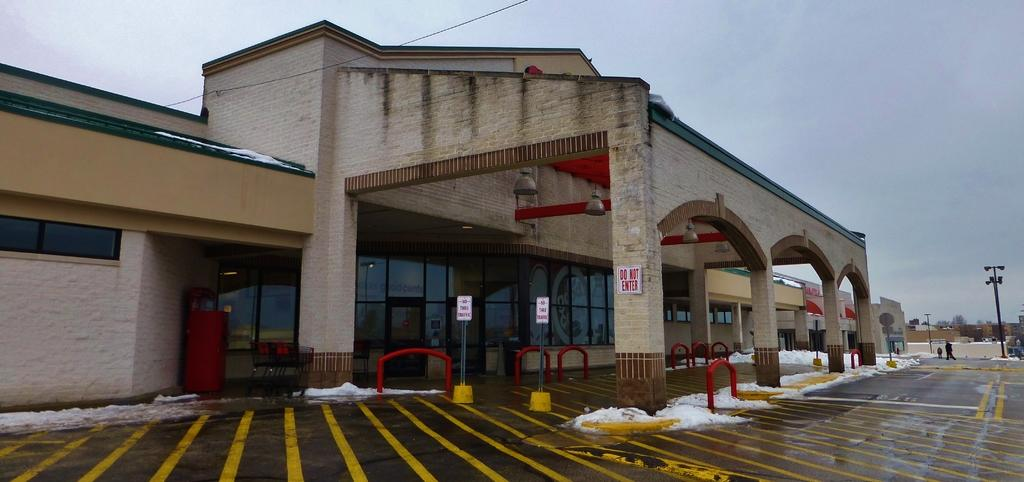<image>
Present a compact description of the photo's key features. A store front with brick columns has a "DO NOT ENTER" sign on one of the columns. 